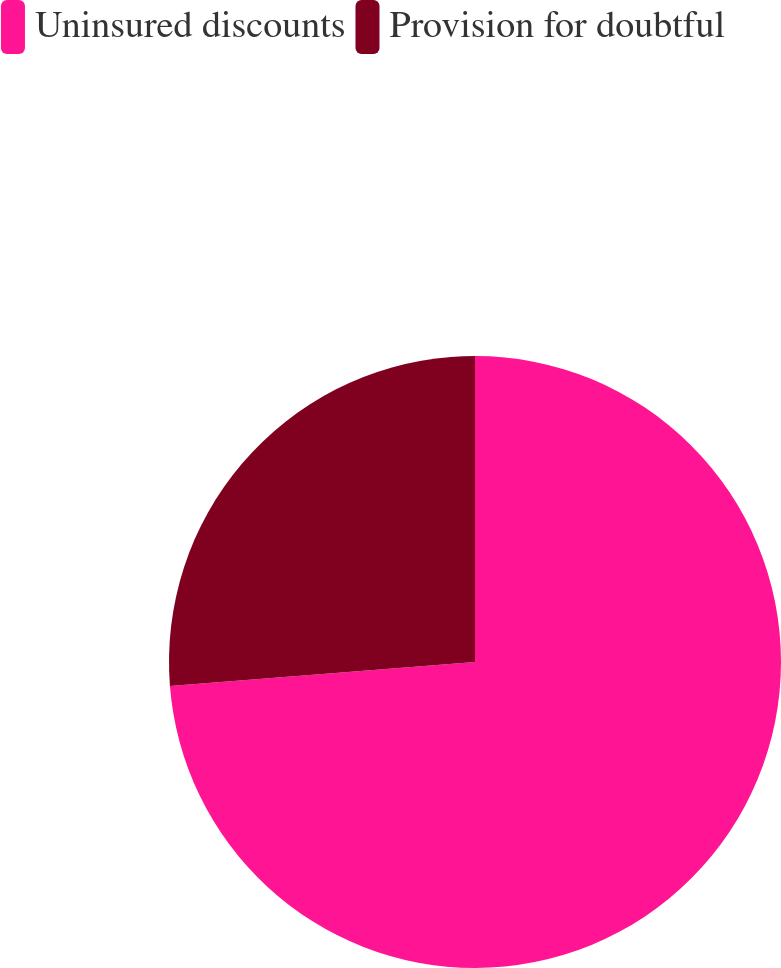Convert chart. <chart><loc_0><loc_0><loc_500><loc_500><pie_chart><fcel>Uninsured discounts<fcel>Provision for doubtful<nl><fcel>73.75%<fcel>26.25%<nl></chart> 